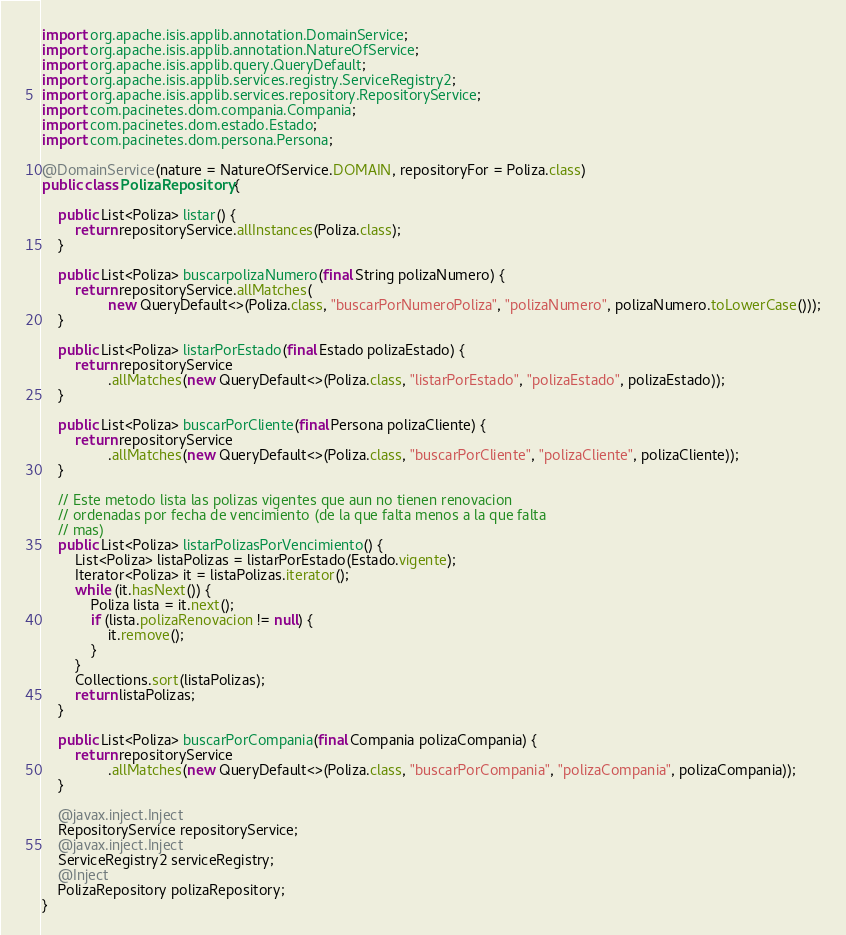Convert code to text. <code><loc_0><loc_0><loc_500><loc_500><_Java_>import org.apache.isis.applib.annotation.DomainService;
import org.apache.isis.applib.annotation.NatureOfService;
import org.apache.isis.applib.query.QueryDefault;
import org.apache.isis.applib.services.registry.ServiceRegistry2;
import org.apache.isis.applib.services.repository.RepositoryService;
import com.pacinetes.dom.compania.Compania;
import com.pacinetes.dom.estado.Estado;
import com.pacinetes.dom.persona.Persona;

@DomainService(nature = NatureOfService.DOMAIN, repositoryFor = Poliza.class)
public class PolizaRepository {

	public List<Poliza> listar() {
		return repositoryService.allInstances(Poliza.class);
	}

	public List<Poliza> buscarpolizaNumero(final String polizaNumero) {
		return repositoryService.allMatches(
				new QueryDefault<>(Poliza.class, "buscarPorNumeroPoliza", "polizaNumero", polizaNumero.toLowerCase()));
	}

	public List<Poliza> listarPorEstado(final Estado polizaEstado) {
		return repositoryService
				.allMatches(new QueryDefault<>(Poliza.class, "listarPorEstado", "polizaEstado", polizaEstado));
	}

	public List<Poliza> buscarPorCliente(final Persona polizaCliente) {
		return repositoryService
				.allMatches(new QueryDefault<>(Poliza.class, "buscarPorCliente", "polizaCliente", polizaCliente));
	}

	// Este metodo lista las polizas vigentes que aun no tienen renovacion
	// ordenadas por fecha de vencimiento (de la que falta menos a la que falta
	// mas)
	public List<Poliza> listarPolizasPorVencimiento() {
		List<Poliza> listaPolizas = listarPorEstado(Estado.vigente);
		Iterator<Poliza> it = listaPolizas.iterator();
		while (it.hasNext()) {
			Poliza lista = it.next();
			if (lista.polizaRenovacion != null) {
				it.remove();
			}
		}
		Collections.sort(listaPolizas);
		return listaPolizas;
	}

	public List<Poliza> buscarPorCompania(final Compania polizaCompania) {
		return repositoryService
				.allMatches(new QueryDefault<>(Poliza.class, "buscarPorCompania", "polizaCompania", polizaCompania));
	}

	@javax.inject.Inject
	RepositoryService repositoryService;
	@javax.inject.Inject
	ServiceRegistry2 serviceRegistry;
	@Inject
	PolizaRepository polizaRepository;
}
</code> 